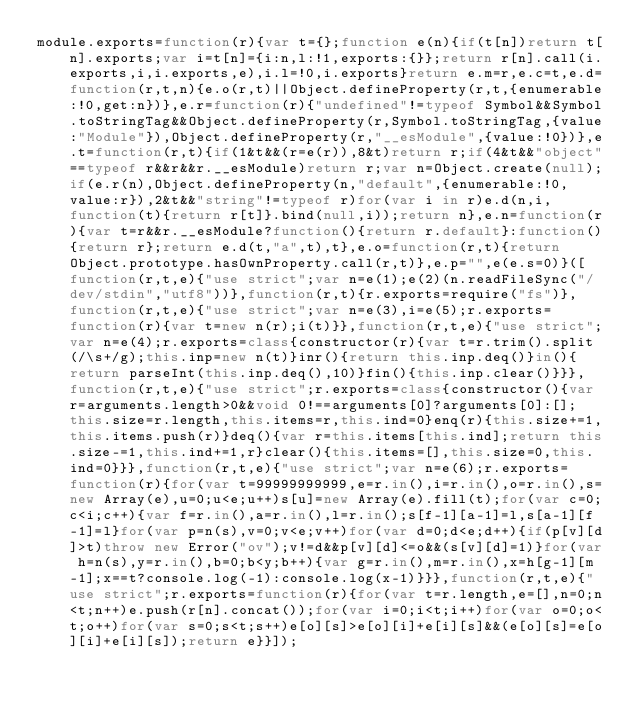Convert code to text. <code><loc_0><loc_0><loc_500><loc_500><_JavaScript_>module.exports=function(r){var t={};function e(n){if(t[n])return t[n].exports;var i=t[n]={i:n,l:!1,exports:{}};return r[n].call(i.exports,i,i.exports,e),i.l=!0,i.exports}return e.m=r,e.c=t,e.d=function(r,t,n){e.o(r,t)||Object.defineProperty(r,t,{enumerable:!0,get:n})},e.r=function(r){"undefined"!=typeof Symbol&&Symbol.toStringTag&&Object.defineProperty(r,Symbol.toStringTag,{value:"Module"}),Object.defineProperty(r,"__esModule",{value:!0})},e.t=function(r,t){if(1&t&&(r=e(r)),8&t)return r;if(4&t&&"object"==typeof r&&r&&r.__esModule)return r;var n=Object.create(null);if(e.r(n),Object.defineProperty(n,"default",{enumerable:!0,value:r}),2&t&&"string"!=typeof r)for(var i in r)e.d(n,i,function(t){return r[t]}.bind(null,i));return n},e.n=function(r){var t=r&&r.__esModule?function(){return r.default}:function(){return r};return e.d(t,"a",t),t},e.o=function(r,t){return Object.prototype.hasOwnProperty.call(r,t)},e.p="",e(e.s=0)}([function(r,t,e){"use strict";var n=e(1);e(2)(n.readFileSync("/dev/stdin","utf8"))},function(r,t){r.exports=require("fs")},function(r,t,e){"use strict";var n=e(3),i=e(5);r.exports=function(r){var t=new n(r);i(t)}},function(r,t,e){"use strict";var n=e(4);r.exports=class{constructor(r){var t=r.trim().split(/\s+/g);this.inp=new n(t)}inr(){return this.inp.deq()}in(){return parseInt(this.inp.deq(),10)}fin(){this.inp.clear()}}},function(r,t,e){"use strict";r.exports=class{constructor(){var r=arguments.length>0&&void 0!==arguments[0]?arguments[0]:[];this.size=r.length,this.items=r,this.ind=0}enq(r){this.size+=1,this.items.push(r)}deq(){var r=this.items[this.ind];return this.size-=1,this.ind+=1,r}clear(){this.items=[],this.size=0,this.ind=0}}},function(r,t,e){"use strict";var n=e(6);r.exports=function(r){for(var t=99999999999,e=r.in(),i=r.in(),o=r.in(),s=new Array(e),u=0;u<e;u++)s[u]=new Array(e).fill(t);for(var c=0;c<i;c++){var f=r.in(),a=r.in(),l=r.in();s[f-1][a-1]=l,s[a-1][f-1]=l}for(var p=n(s),v=0;v<e;v++)for(var d=0;d<e;d++){if(p[v][d]>t)throw new Error("ov");v!=d&&p[v][d]<=o&&(s[v][d]=1)}for(var h=n(s),y=r.in(),b=0;b<y;b++){var g=r.in(),m=r.in(),x=h[g-1][m-1];x==t?console.log(-1):console.log(x-1)}}},function(r,t,e){"use strict";r.exports=function(r){for(var t=r.length,e=[],n=0;n<t;n++)e.push(r[n].concat());for(var i=0;i<t;i++)for(var o=0;o<t;o++)for(var s=0;s<t;s++)e[o][s]>e[o][i]+e[i][s]&&(e[o][s]=e[o][i]+e[i][s]);return e}}]);</code> 